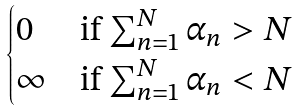<formula> <loc_0><loc_0><loc_500><loc_500>\begin{cases} 0 & \text {if $\sum_{n=1}^{N}\alpha_{n}>N$} \\ \infty & \text {if $\sum_{n=1}^{N}\alpha_{n}<N$} \end{cases}</formula> 